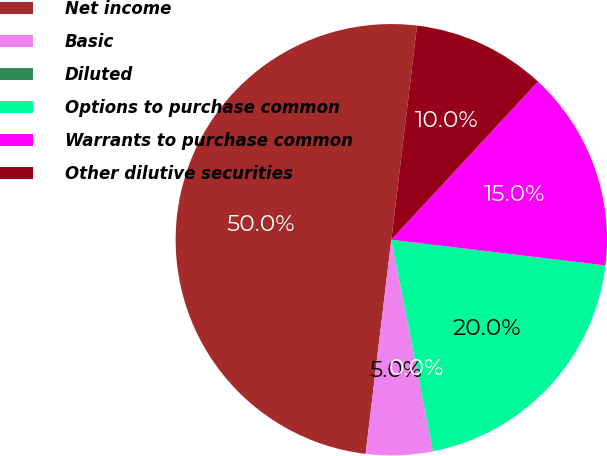<chart> <loc_0><loc_0><loc_500><loc_500><pie_chart><fcel>Net income<fcel>Basic<fcel>Diluted<fcel>Options to purchase common<fcel>Warrants to purchase common<fcel>Other dilutive securities<nl><fcel>50.0%<fcel>5.0%<fcel>0.0%<fcel>20.0%<fcel>15.0%<fcel>10.0%<nl></chart> 